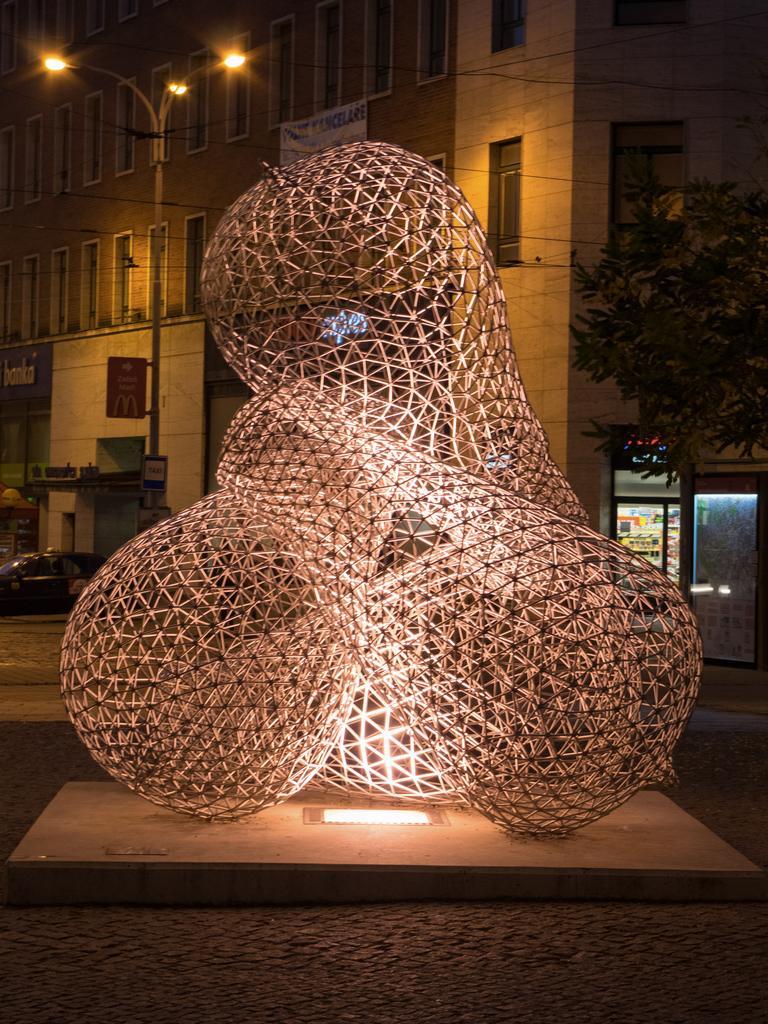In one or two sentences, can you explain what this image depicts? In the front of the image there is a platform, light and mesh sculpture. In the background of the image there is a building, banner, boards, lights, vehicle, pole, store, tree and objects.   